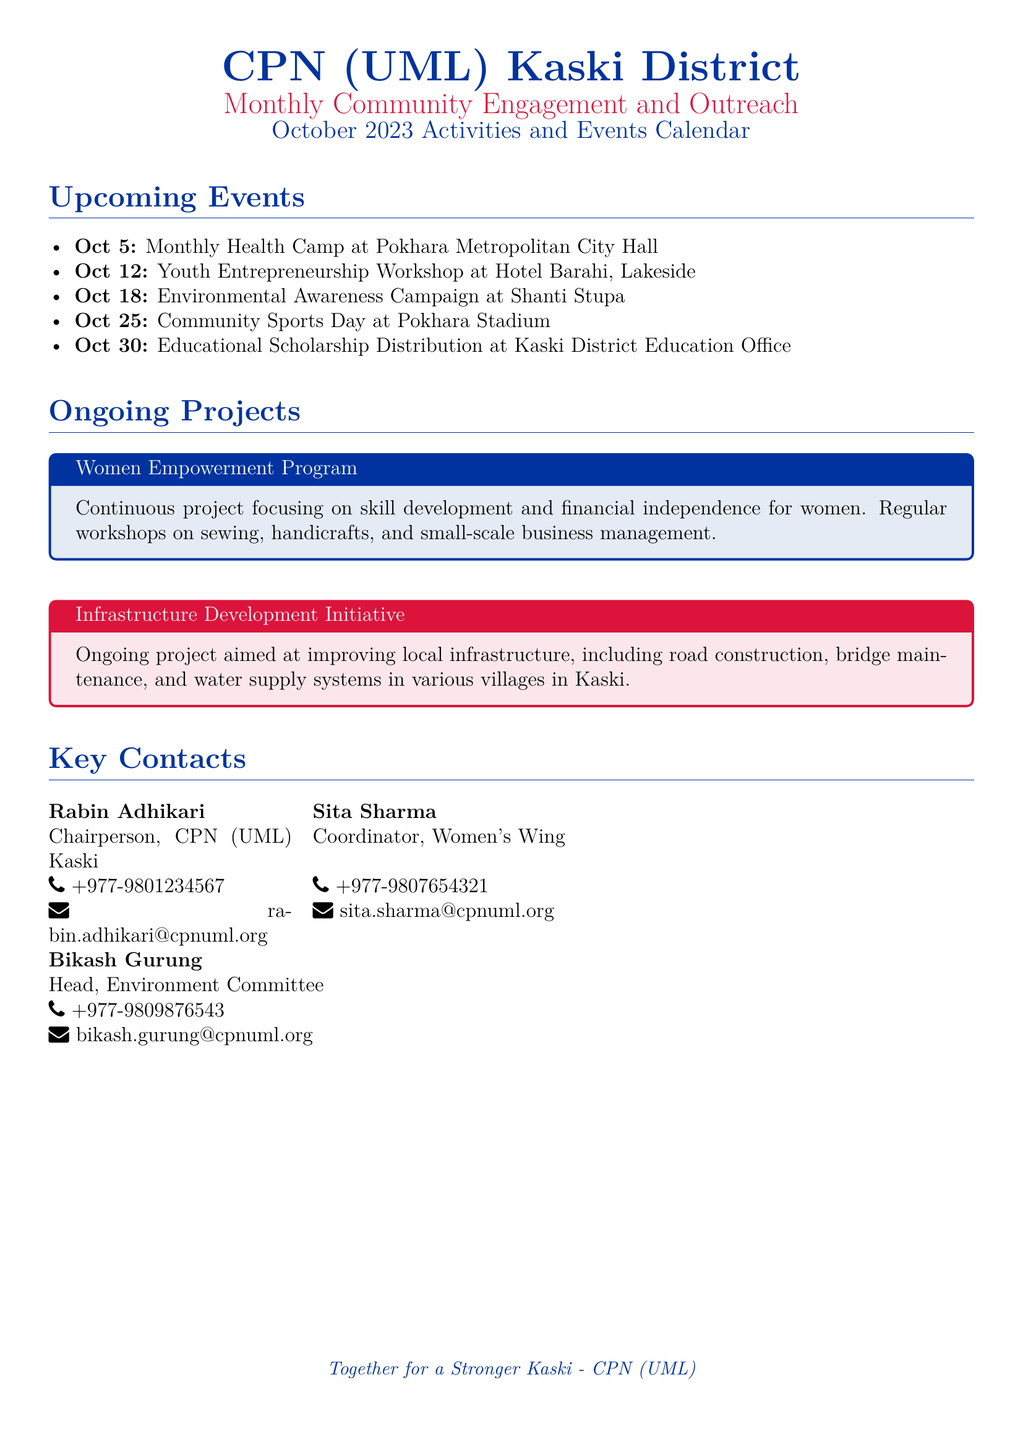What is the date of the Monthly Health Camp? The date of the Monthly Health Camp is mentioned under Upcoming Events.
Answer: Oct 5 Where will the Youth Entrepreneurship Workshop be held? The location of the Youth Entrepreneurship Workshop is specified in the document.
Answer: Hotel Barahi, Lakeside What is the main focus of the Women Empowerment Program? The main focus of the Women Empowerment Program is stated in the description of the ongoing project.
Answer: Skill development and financial independence for women Who is the Chairperson of CPN (UML) Kaski? The name of the Chairperson is listed in the Key Contacts section.
Answer: Rabin Adhikari What is the purpose of the Educational Scholarship Distribution event? The purpose of the event is described in the Upcoming Events section.
Answer: Educational Scholarships How many ongoing projects are mentioned in the document? The document lists two ongoing projects in the relevant section.
Answer: 2 Who is the Coordinator of the Women's Wing? The name and title are provided in the Key Contacts section.
Answer: Sita Sharma What type of event is scheduled for Oct 25? The nature of the event is included in the Upcoming Events list.
Answer: Community Sports Day 